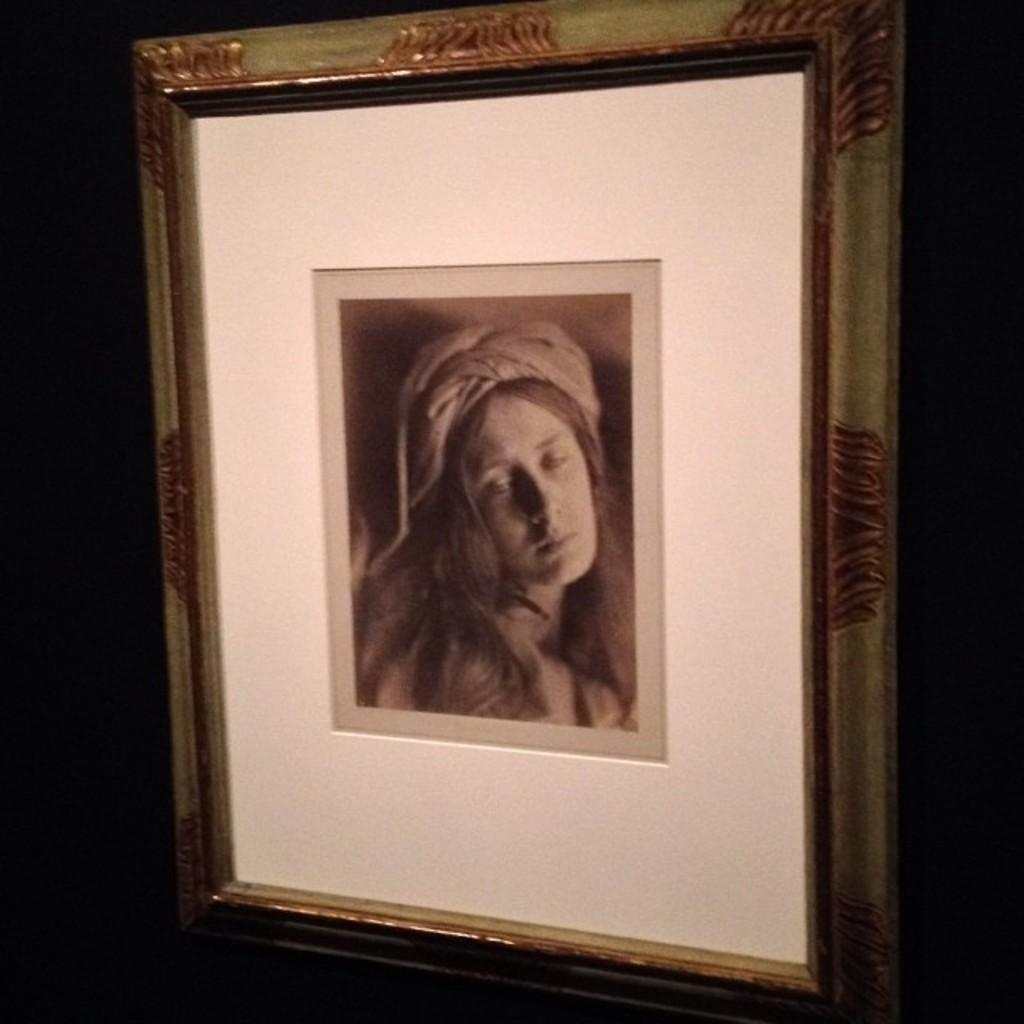What object is present in the image that typically holds a photograph? There is a photo frame in the image. What can be seen inside the photo frame? The photo frame contains a photograph of a woman. How many borders are visible around the photograph in the image? There are no borders visible around the photograph in the image; it is contained within the photo frame. 